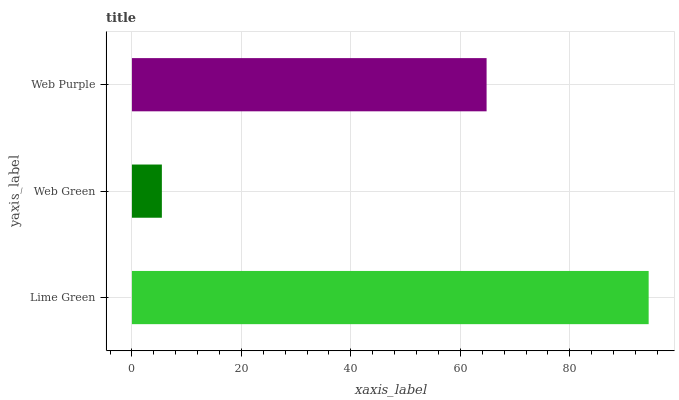Is Web Green the minimum?
Answer yes or no. Yes. Is Lime Green the maximum?
Answer yes or no. Yes. Is Web Purple the minimum?
Answer yes or no. No. Is Web Purple the maximum?
Answer yes or no. No. Is Web Purple greater than Web Green?
Answer yes or no. Yes. Is Web Green less than Web Purple?
Answer yes or no. Yes. Is Web Green greater than Web Purple?
Answer yes or no. No. Is Web Purple less than Web Green?
Answer yes or no. No. Is Web Purple the high median?
Answer yes or no. Yes. Is Web Purple the low median?
Answer yes or no. Yes. Is Web Green the high median?
Answer yes or no. No. Is Web Green the low median?
Answer yes or no. No. 